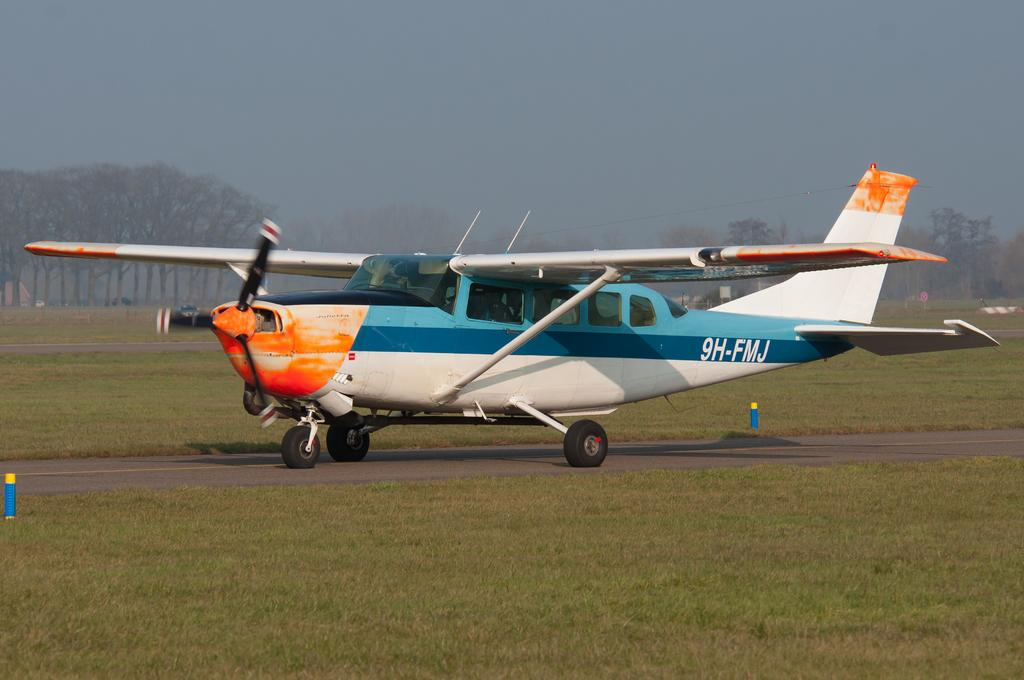What is the main subject in the center of the image? There is an aircraft in the center of the image. What type of terrain is visible in the image? There is grassland in the image. What can be seen in the background of the image? There are trees in the background area of the image. How many bushes are there in the image? There is no mention of bushes in the image; it features an aircraft, grassland, and trees. 